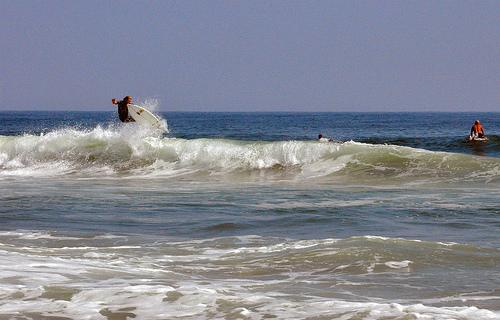Question: when was this picture taken?
Choices:
A. Day time.
B. Night time.
C. Noon.
D. Dusk.
Answer with the letter. Answer: A Question: what is the sky's present condition?
Choices:
A. Cloudy.
B. Rainy.
C. Clear.
D. Snowy.
Answer with the letter. Answer: C Question: where was this photo taken?
Choices:
A. Lake.
B. The ocean.
C. Stream.
D. Brook.
Answer with the letter. Answer: B 